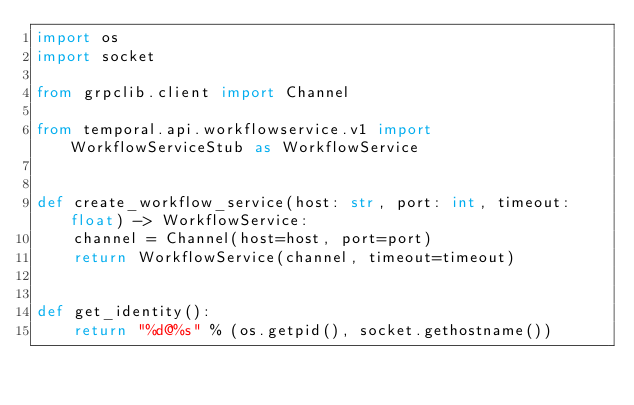<code> <loc_0><loc_0><loc_500><loc_500><_Python_>import os
import socket

from grpclib.client import Channel

from temporal.api.workflowservice.v1 import WorkflowServiceStub as WorkflowService


def create_workflow_service(host: str, port: int, timeout: float) -> WorkflowService:
    channel = Channel(host=host, port=port)
    return WorkflowService(channel, timeout=timeout)


def get_identity():
    return "%d@%s" % (os.getpid(), socket.gethostname())

</code> 